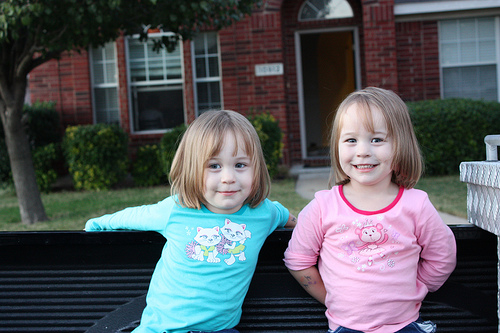<image>
Is there a leaves above the ground? Yes. The leaves is positioned above the ground in the vertical space, higher up in the scene. 